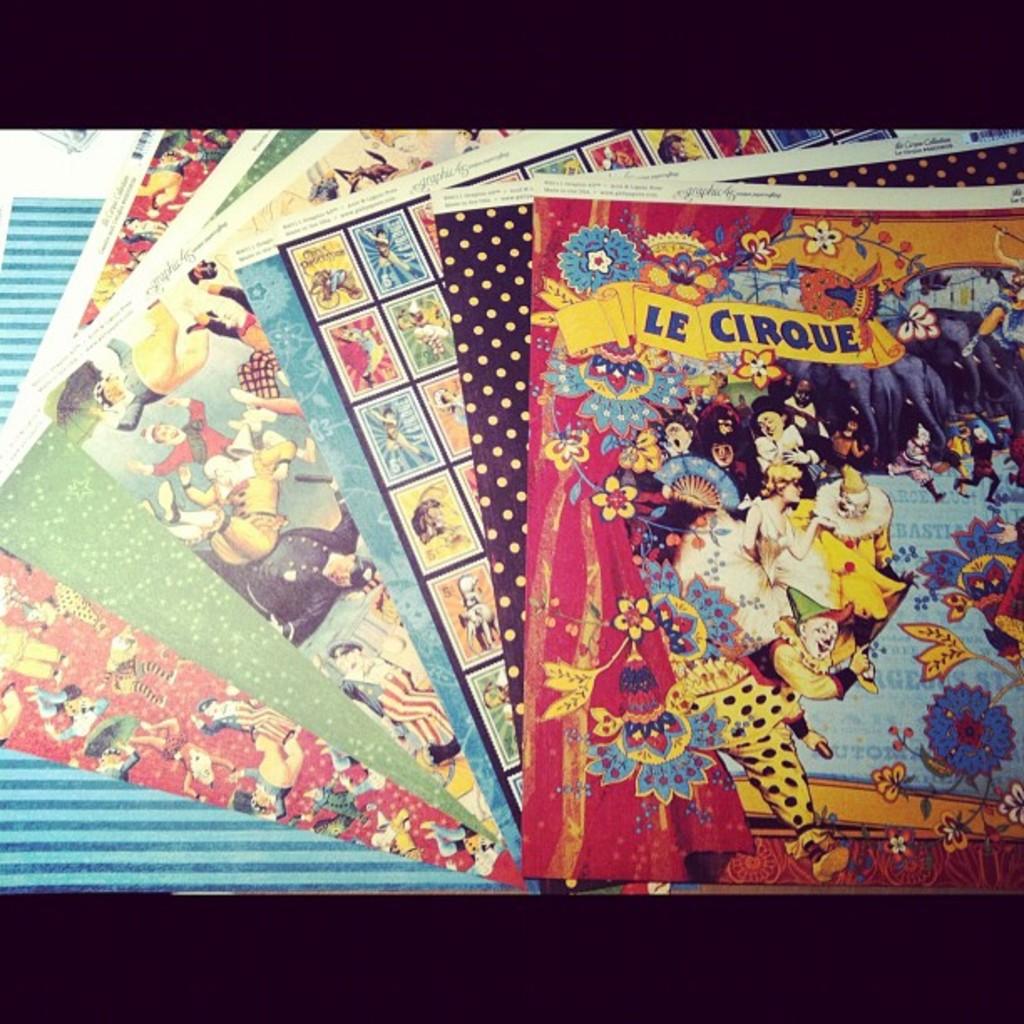What is featured on the front card?
Ensure brevity in your answer.  Le cirque. What´s the name of the first poster?
Give a very brief answer. Le cirque. 